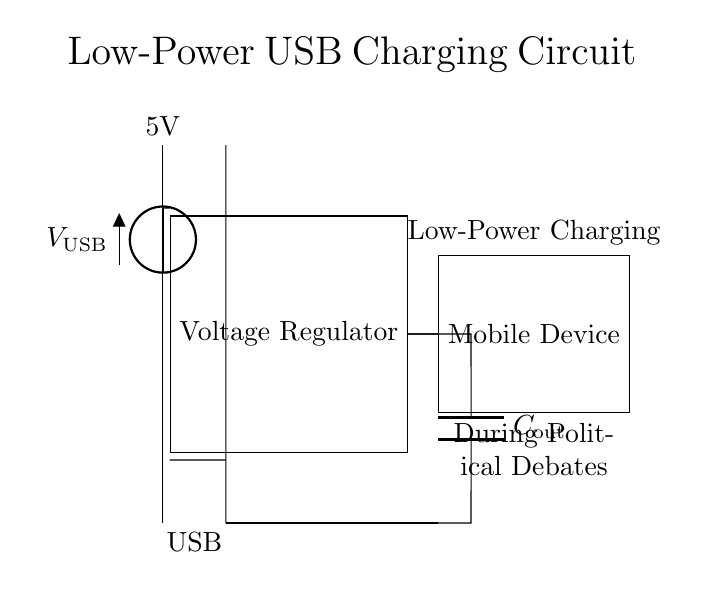What is the voltage of this circuit? The voltage of this circuit is 5V, as indicated by the label next to the voltage source, which represents the USB power supply.
Answer: 5V What is the purpose of the voltage regulator in this circuit? The voltage regulator converts the input voltage from the USB socket to a stable output voltage suitable for charging. This is essential for ensuring that the connected device receives a consistent voltage.
Answer: Stable output voltage What component is connected to the output of the voltage regulator? The output of the voltage regulator is connected to a capacitor, labeled as C out, which helps to smooth the output voltage and reduce fluctuations.
Answer: Capacitor How many major components are present in this circuit? There are three major components in this circuit: the voltage regulator, the output capacitor, and the mobile device (load). These are essential for the functioning of the charging circuit.
Answer: Three What kind of device is this circuit designed to charge? This low-power USB charging circuit is specifically designed for mobile devices, as mentioned in the label near the load component.
Answer: Mobile devices Why is it important for this circuit to be low power? Low power consumption in this circuit is crucial for maintaining battery life during political debates, where uninterrupted functionality is needed without overloading the power supply or causing heating issues.
Answer: Maintains battery life 